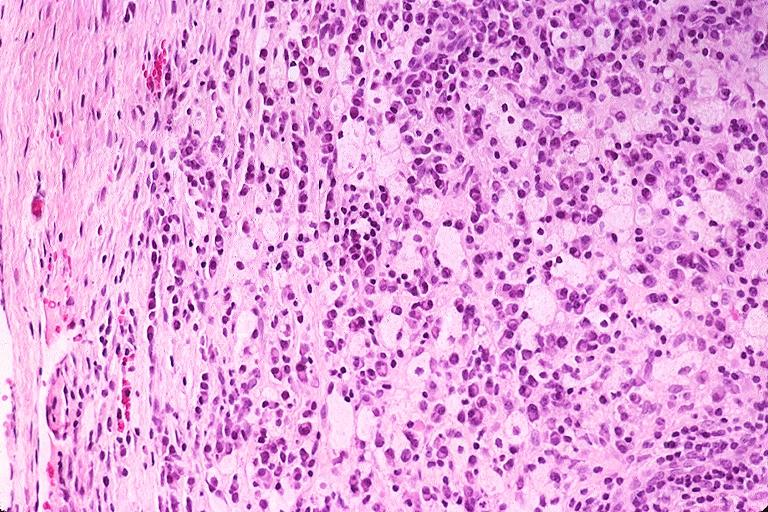does this image show periapical granuloma?
Answer the question using a single word or phrase. Yes 